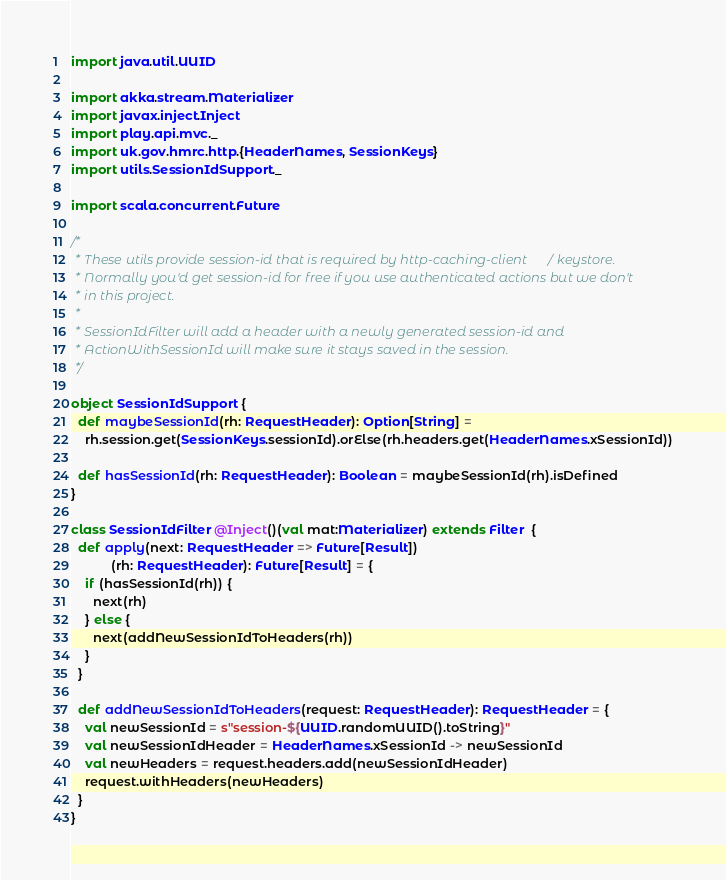<code> <loc_0><loc_0><loc_500><loc_500><_Scala_>import java.util.UUID

import akka.stream.Materializer
import javax.inject.Inject
import play.api.mvc._
import uk.gov.hmrc.http.{HeaderNames, SessionKeys}
import utils.SessionIdSupport._

import scala.concurrent.Future

/*
 * These utils provide session-id that is required by http-caching-client / keystore.
 * Normally you'd get session-id for free if you use authenticated actions but we don't
 * in this project.
 *
 * SessionIdFilter will add a header with a newly generated session-id and
 * ActionWithSessionId will make sure it stays saved in the session.
 */

object SessionIdSupport {
  def maybeSessionId(rh: RequestHeader): Option[String] =
    rh.session.get(SessionKeys.sessionId).orElse(rh.headers.get(HeaderNames.xSessionId))

  def hasSessionId(rh: RequestHeader): Boolean = maybeSessionId(rh).isDefined
}

class SessionIdFilter @Inject()(val mat:Materializer) extends Filter  {
  def apply(next: RequestHeader => Future[Result])
           (rh: RequestHeader): Future[Result] = {
    if (hasSessionId(rh)) {
      next(rh)
    } else {
      next(addNewSessionIdToHeaders(rh))
    }
  }

  def addNewSessionIdToHeaders(request: RequestHeader): RequestHeader = {
    val newSessionId = s"session-${UUID.randomUUID().toString}"
    val newSessionIdHeader = HeaderNames.xSessionId -> newSessionId
    val newHeaders = request.headers.add(newSessionIdHeader)
    request.withHeaders(newHeaders)
  }
}</code> 